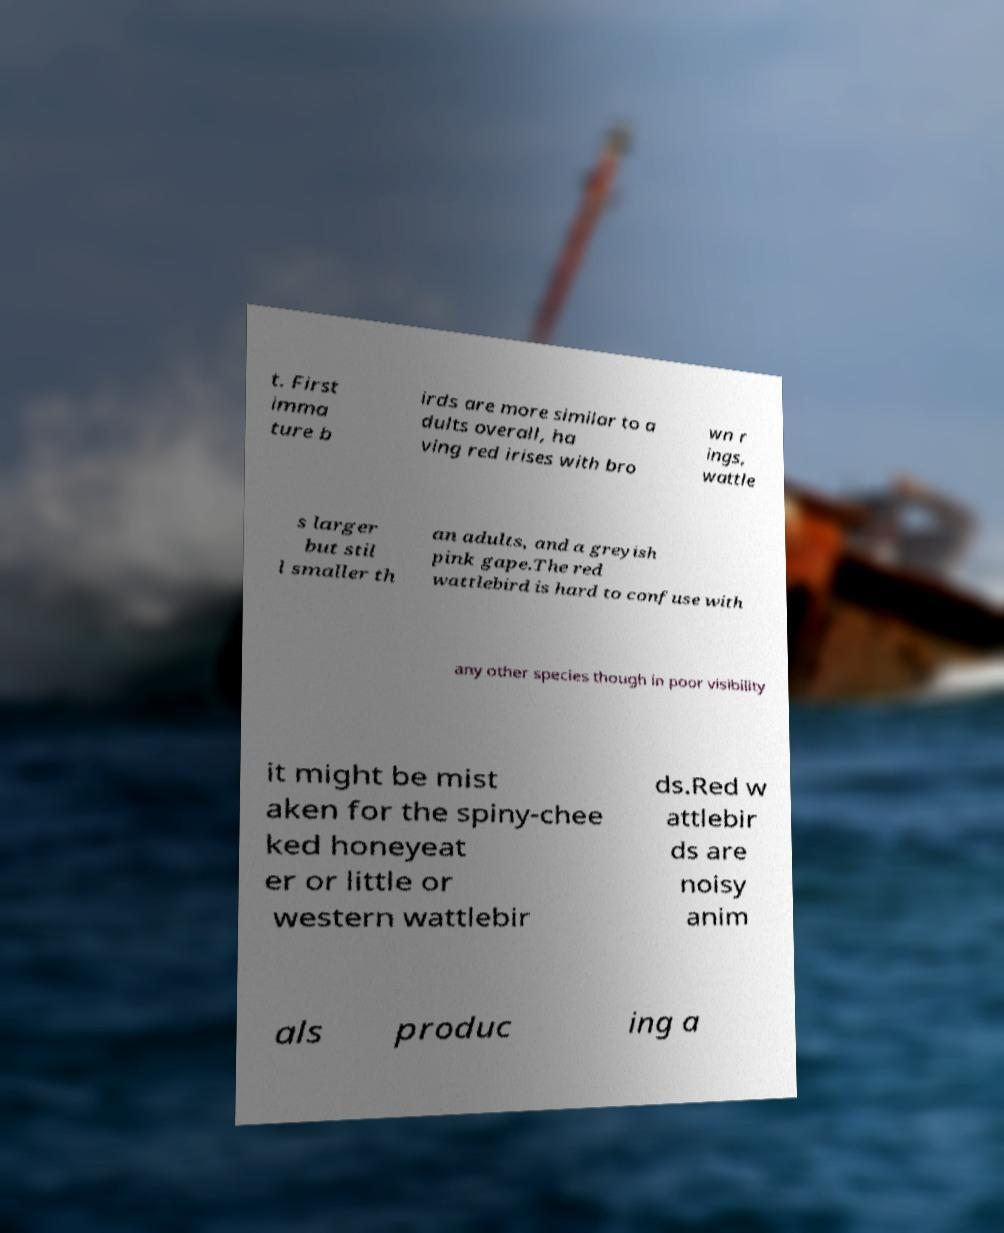Please identify and transcribe the text found in this image. t. First imma ture b irds are more similar to a dults overall, ha ving red irises with bro wn r ings, wattle s larger but stil l smaller th an adults, and a greyish pink gape.The red wattlebird is hard to confuse with any other species though in poor visibility it might be mist aken for the spiny-chee ked honeyeat er or little or western wattlebir ds.Red w attlebir ds are noisy anim als produc ing a 